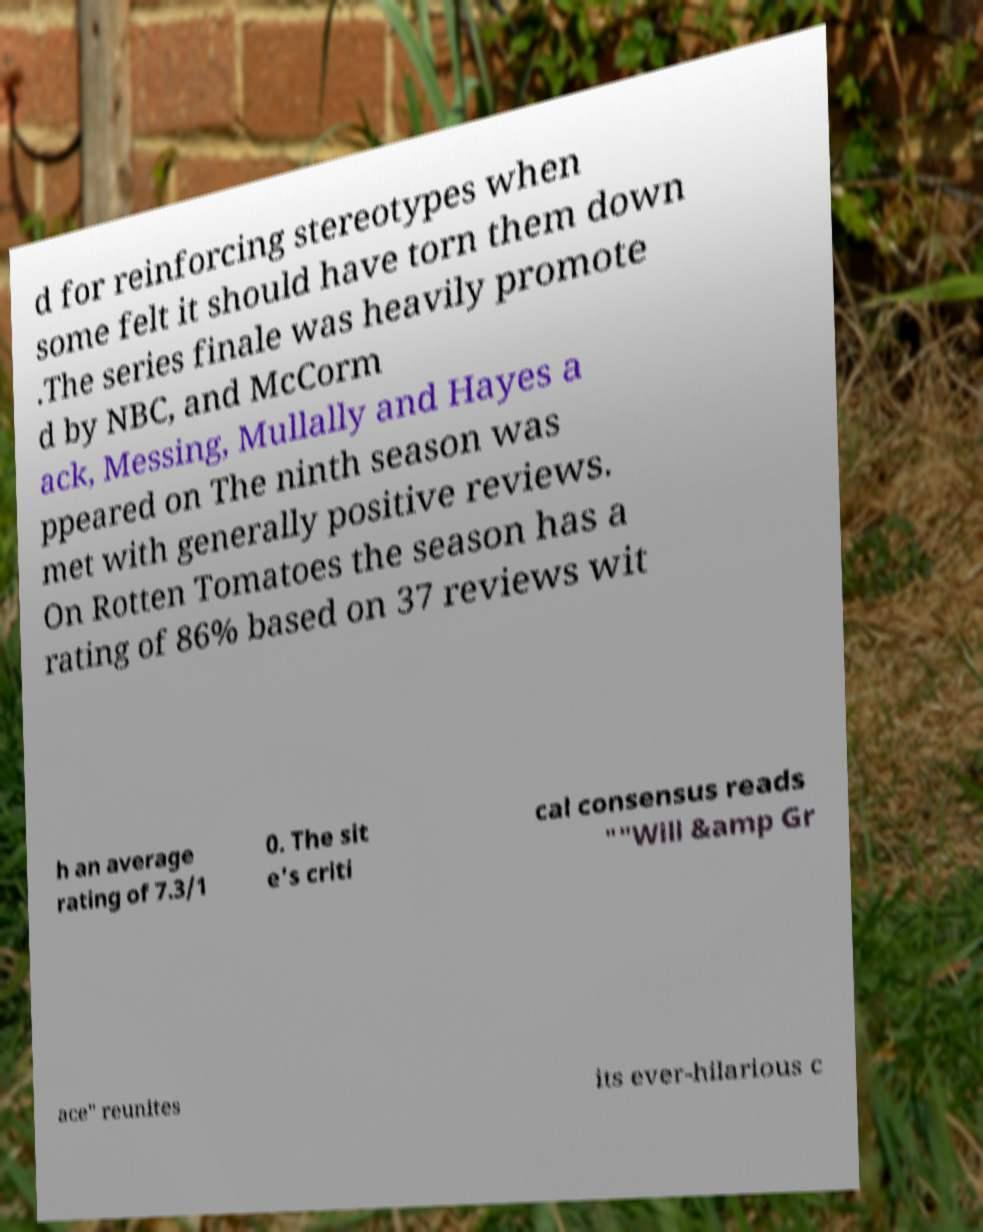Can you accurately transcribe the text from the provided image for me? d for reinforcing stereotypes when some felt it should have torn them down .The series finale was heavily promote d by NBC, and McCorm ack, Messing, Mullally and Hayes a ppeared on The ninth season was met with generally positive reviews. On Rotten Tomatoes the season has a rating of 86% based on 37 reviews wit h an average rating of 7.3/1 0. The sit e's criti cal consensus reads ""Will &amp Gr ace" reunites its ever-hilarious c 